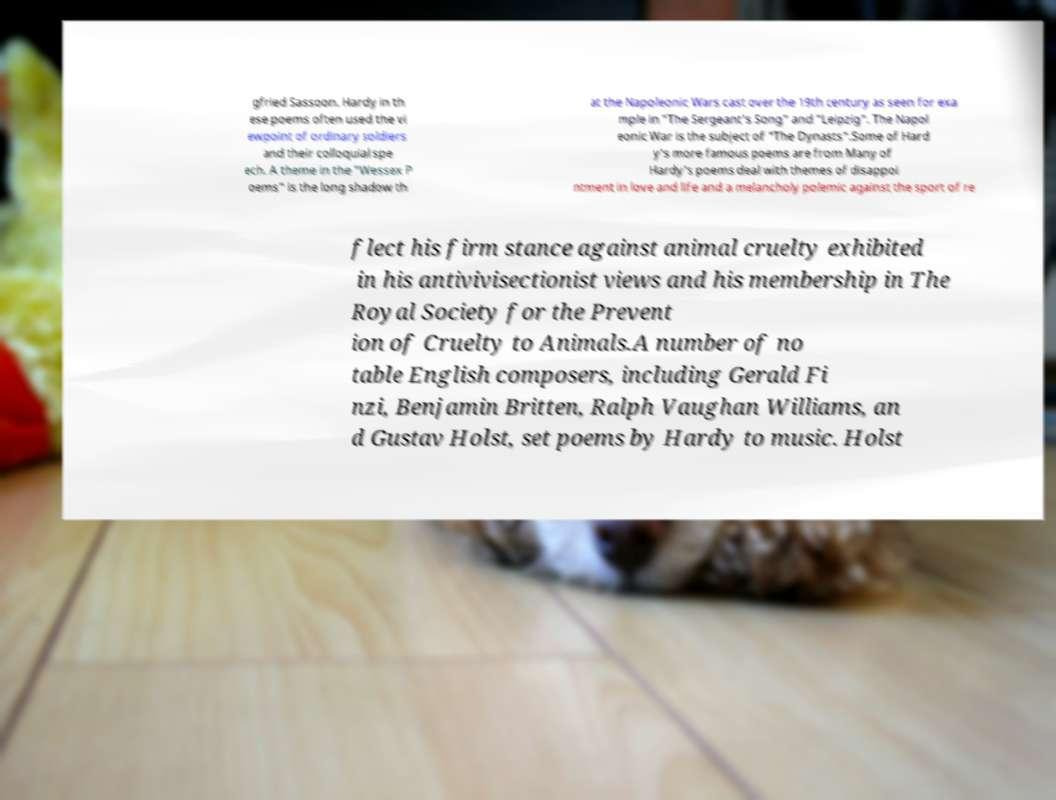For documentation purposes, I need the text within this image transcribed. Could you provide that? gfried Sassoon. Hardy in th ese poems often used the vi ewpoint of ordinary soldiers and their colloquial spe ech. A theme in the "Wessex P oems" is the long shadow th at the Napoleonic Wars cast over the 19th century as seen for exa mple in "The Sergeant's Song" and "Leipzig". The Napol eonic War is the subject of "The Dynasts".Some of Hard y's more famous poems are from Many of Hardy's poems deal with themes of disappoi ntment in love and life and a melancholy polemic against the sport of re flect his firm stance against animal cruelty exhibited in his antivivisectionist views and his membership in The Royal Society for the Prevent ion of Cruelty to Animals.A number of no table English composers, including Gerald Fi nzi, Benjamin Britten, Ralph Vaughan Williams, an d Gustav Holst, set poems by Hardy to music. Holst 